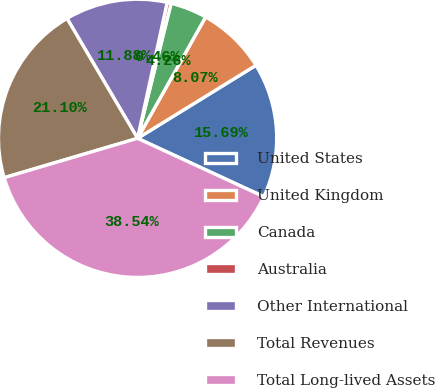Convert chart to OTSL. <chart><loc_0><loc_0><loc_500><loc_500><pie_chart><fcel>United States<fcel>United Kingdom<fcel>Canada<fcel>Australia<fcel>Other International<fcel>Total Revenues<fcel>Total Long-lived Assets<nl><fcel>15.69%<fcel>8.07%<fcel>4.26%<fcel>0.46%<fcel>11.88%<fcel>21.1%<fcel>38.54%<nl></chart> 